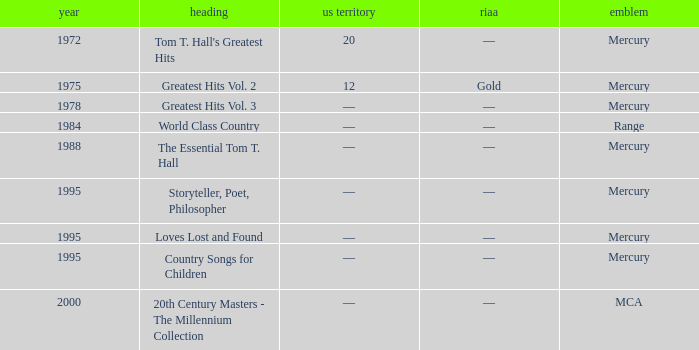What is the title of the album that had a RIAA of gold? Greatest Hits Vol. 2. Help me parse the entirety of this table. {'header': ['year', 'heading', 'us territory', 'riaa', 'emblem'], 'rows': [['1972', "Tom T. Hall's Greatest Hits", '20', '—', 'Mercury'], ['1975', 'Greatest Hits Vol. 2', '12', 'Gold', 'Mercury'], ['1978', 'Greatest Hits Vol. 3', '—', '—', 'Mercury'], ['1984', 'World Class Country', '—', '—', 'Range'], ['1988', 'The Essential Tom T. Hall', '—', '—', 'Mercury'], ['1995', 'Storyteller, Poet, Philosopher', '—', '—', 'Mercury'], ['1995', 'Loves Lost and Found', '—', '—', 'Mercury'], ['1995', 'Country Songs for Children', '—', '—', 'Mercury'], ['2000', '20th Century Masters - The Millennium Collection', '—', '—', 'MCA']]} 